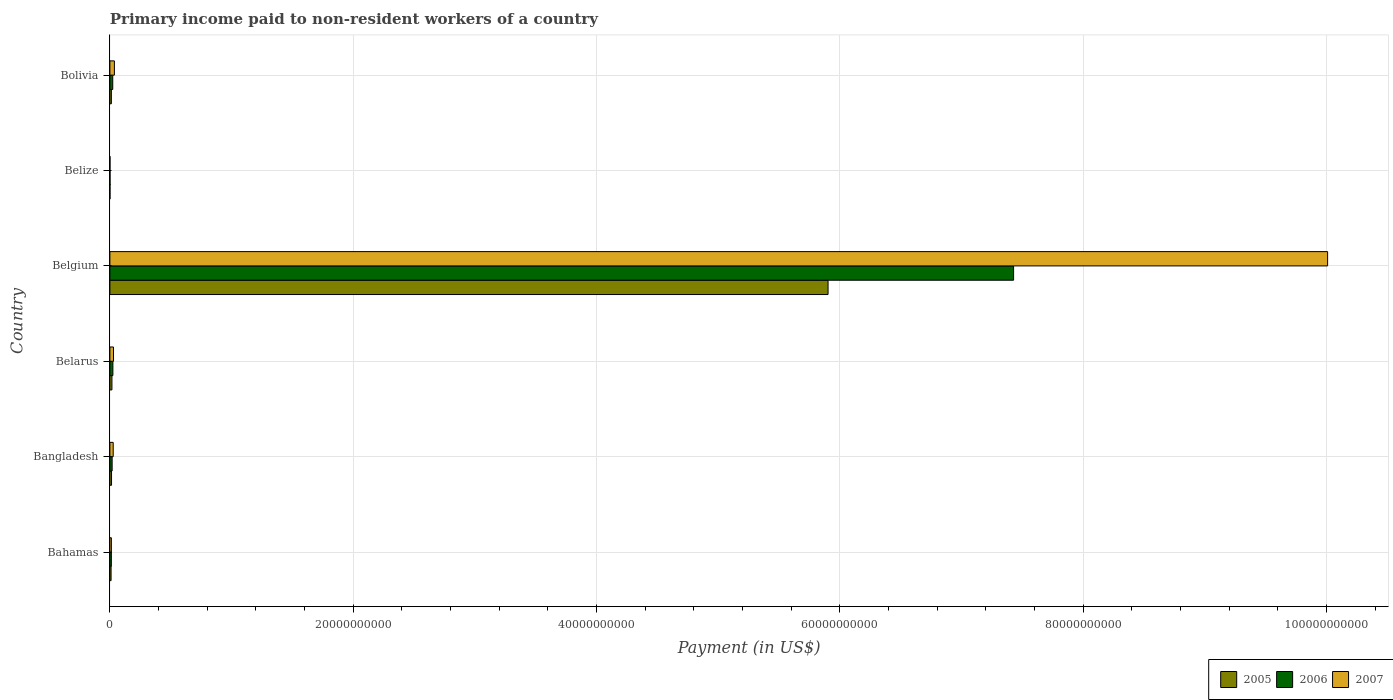How many different coloured bars are there?
Your response must be concise. 3. How many groups of bars are there?
Your answer should be very brief. 6. Are the number of bars per tick equal to the number of legend labels?
Make the answer very short. Yes. Are the number of bars on each tick of the Y-axis equal?
Make the answer very short. Yes. How many bars are there on the 6th tick from the top?
Give a very brief answer. 3. What is the amount paid to workers in 2006 in Belize?
Make the answer very short. 1.01e+07. Across all countries, what is the maximum amount paid to workers in 2005?
Keep it short and to the point. 5.90e+1. Across all countries, what is the minimum amount paid to workers in 2007?
Keep it short and to the point. 6.97e+06. In which country was the amount paid to workers in 2006 maximum?
Your response must be concise. Belgium. In which country was the amount paid to workers in 2006 minimum?
Give a very brief answer. Belize. What is the total amount paid to workers in 2005 in the graph?
Keep it short and to the point. 5.96e+1. What is the difference between the amount paid to workers in 2007 in Bangladesh and that in Belgium?
Your answer should be very brief. -9.98e+1. What is the difference between the amount paid to workers in 2007 in Bahamas and the amount paid to workers in 2005 in Belarus?
Keep it short and to the point. -4.71e+07. What is the average amount paid to workers in 2007 per country?
Your answer should be very brief. 1.69e+1. What is the difference between the amount paid to workers in 2007 and amount paid to workers in 2005 in Belgium?
Your response must be concise. 4.11e+1. In how many countries, is the amount paid to workers in 2007 greater than 12000000000 US$?
Ensure brevity in your answer.  1. What is the ratio of the amount paid to workers in 2005 in Belarus to that in Bolivia?
Offer a very short reply. 1.39. Is the difference between the amount paid to workers in 2007 in Belgium and Bolivia greater than the difference between the amount paid to workers in 2005 in Belgium and Bolivia?
Offer a terse response. Yes. What is the difference between the highest and the second highest amount paid to workers in 2007?
Offer a terse response. 9.97e+1. What is the difference between the highest and the lowest amount paid to workers in 2006?
Offer a very short reply. 7.43e+1. Is the sum of the amount paid to workers in 2007 in Bahamas and Belarus greater than the maximum amount paid to workers in 2005 across all countries?
Ensure brevity in your answer.  No. What does the 1st bar from the top in Bahamas represents?
Your response must be concise. 2007. What does the 2nd bar from the bottom in Bahamas represents?
Keep it short and to the point. 2006. Is it the case that in every country, the sum of the amount paid to workers in 2007 and amount paid to workers in 2005 is greater than the amount paid to workers in 2006?
Ensure brevity in your answer.  Yes. How many bars are there?
Your response must be concise. 18. Are all the bars in the graph horizontal?
Offer a terse response. Yes. How many countries are there in the graph?
Offer a very short reply. 6. What is the difference between two consecutive major ticks on the X-axis?
Offer a terse response. 2.00e+1. How many legend labels are there?
Your response must be concise. 3. What is the title of the graph?
Keep it short and to the point. Primary income paid to non-resident workers of a country. Does "1985" appear as one of the legend labels in the graph?
Provide a succinct answer. No. What is the label or title of the X-axis?
Give a very brief answer. Payment (in US$). What is the label or title of the Y-axis?
Offer a terse response. Country. What is the Payment (in US$) in 2005 in Bahamas?
Offer a terse response. 9.70e+07. What is the Payment (in US$) of 2006 in Bahamas?
Offer a very short reply. 1.19e+08. What is the Payment (in US$) in 2007 in Bahamas?
Provide a short and direct response. 1.21e+08. What is the Payment (in US$) of 2005 in Bangladesh?
Keep it short and to the point. 1.35e+08. What is the Payment (in US$) of 2006 in Bangladesh?
Keep it short and to the point. 1.84e+08. What is the Payment (in US$) of 2007 in Bangladesh?
Provide a succinct answer. 2.72e+08. What is the Payment (in US$) in 2005 in Belarus?
Keep it short and to the point. 1.68e+08. What is the Payment (in US$) in 2006 in Belarus?
Your answer should be compact. 2.47e+08. What is the Payment (in US$) in 2007 in Belarus?
Keep it short and to the point. 2.97e+08. What is the Payment (in US$) of 2005 in Belgium?
Your answer should be very brief. 5.90e+1. What is the Payment (in US$) of 2006 in Belgium?
Provide a short and direct response. 7.43e+1. What is the Payment (in US$) of 2007 in Belgium?
Provide a succinct answer. 1.00e+11. What is the Payment (in US$) of 2005 in Belize?
Provide a short and direct response. 6.78e+06. What is the Payment (in US$) in 2006 in Belize?
Keep it short and to the point. 1.01e+07. What is the Payment (in US$) in 2007 in Belize?
Provide a short and direct response. 6.97e+06. What is the Payment (in US$) in 2005 in Bolivia?
Offer a very short reply. 1.21e+08. What is the Payment (in US$) of 2006 in Bolivia?
Make the answer very short. 2.35e+08. What is the Payment (in US$) in 2007 in Bolivia?
Give a very brief answer. 3.70e+08. Across all countries, what is the maximum Payment (in US$) in 2005?
Your answer should be very brief. 5.90e+1. Across all countries, what is the maximum Payment (in US$) in 2006?
Your answer should be very brief. 7.43e+1. Across all countries, what is the maximum Payment (in US$) in 2007?
Offer a very short reply. 1.00e+11. Across all countries, what is the minimum Payment (in US$) of 2005?
Offer a very short reply. 6.78e+06. Across all countries, what is the minimum Payment (in US$) in 2006?
Your response must be concise. 1.01e+07. Across all countries, what is the minimum Payment (in US$) of 2007?
Give a very brief answer. 6.97e+06. What is the total Payment (in US$) in 2005 in the graph?
Keep it short and to the point. 5.96e+1. What is the total Payment (in US$) in 2006 in the graph?
Your answer should be very brief. 7.51e+1. What is the total Payment (in US$) of 2007 in the graph?
Offer a very short reply. 1.01e+11. What is the difference between the Payment (in US$) in 2005 in Bahamas and that in Bangladesh?
Offer a very short reply. -3.82e+07. What is the difference between the Payment (in US$) in 2006 in Bahamas and that in Bangladesh?
Make the answer very short. -6.50e+07. What is the difference between the Payment (in US$) of 2007 in Bahamas and that in Bangladesh?
Offer a very short reply. -1.50e+08. What is the difference between the Payment (in US$) of 2005 in Bahamas and that in Belarus?
Offer a very short reply. -7.14e+07. What is the difference between the Payment (in US$) in 2006 in Bahamas and that in Belarus?
Your answer should be compact. -1.27e+08. What is the difference between the Payment (in US$) in 2007 in Bahamas and that in Belarus?
Make the answer very short. -1.76e+08. What is the difference between the Payment (in US$) of 2005 in Bahamas and that in Belgium?
Provide a succinct answer. -5.89e+1. What is the difference between the Payment (in US$) of 2006 in Bahamas and that in Belgium?
Make the answer very short. -7.42e+1. What is the difference between the Payment (in US$) in 2007 in Bahamas and that in Belgium?
Ensure brevity in your answer.  -1.00e+11. What is the difference between the Payment (in US$) of 2005 in Bahamas and that in Belize?
Keep it short and to the point. 9.02e+07. What is the difference between the Payment (in US$) in 2006 in Bahamas and that in Belize?
Give a very brief answer. 1.09e+08. What is the difference between the Payment (in US$) in 2007 in Bahamas and that in Belize?
Provide a short and direct response. 1.14e+08. What is the difference between the Payment (in US$) of 2005 in Bahamas and that in Bolivia?
Offer a very short reply. -2.42e+07. What is the difference between the Payment (in US$) in 2006 in Bahamas and that in Bolivia?
Your answer should be very brief. -1.16e+08. What is the difference between the Payment (in US$) of 2007 in Bahamas and that in Bolivia?
Make the answer very short. -2.49e+08. What is the difference between the Payment (in US$) of 2005 in Bangladesh and that in Belarus?
Give a very brief answer. -3.32e+07. What is the difference between the Payment (in US$) in 2006 in Bangladesh and that in Belarus?
Keep it short and to the point. -6.22e+07. What is the difference between the Payment (in US$) in 2007 in Bangladesh and that in Belarus?
Keep it short and to the point. -2.54e+07. What is the difference between the Payment (in US$) in 2005 in Bangladesh and that in Belgium?
Your response must be concise. -5.89e+1. What is the difference between the Payment (in US$) in 2006 in Bangladesh and that in Belgium?
Provide a short and direct response. -7.41e+1. What is the difference between the Payment (in US$) in 2007 in Bangladesh and that in Belgium?
Keep it short and to the point. -9.98e+1. What is the difference between the Payment (in US$) of 2005 in Bangladesh and that in Belize?
Keep it short and to the point. 1.28e+08. What is the difference between the Payment (in US$) in 2006 in Bangladesh and that in Belize?
Offer a very short reply. 1.74e+08. What is the difference between the Payment (in US$) in 2007 in Bangladesh and that in Belize?
Offer a terse response. 2.65e+08. What is the difference between the Payment (in US$) of 2005 in Bangladesh and that in Bolivia?
Offer a terse response. 1.39e+07. What is the difference between the Payment (in US$) in 2006 in Bangladesh and that in Bolivia?
Give a very brief answer. -5.10e+07. What is the difference between the Payment (in US$) of 2007 in Bangladesh and that in Bolivia?
Offer a terse response. -9.81e+07. What is the difference between the Payment (in US$) of 2005 in Belarus and that in Belgium?
Make the answer very short. -5.89e+1. What is the difference between the Payment (in US$) of 2006 in Belarus and that in Belgium?
Make the answer very short. -7.40e+1. What is the difference between the Payment (in US$) in 2007 in Belarus and that in Belgium?
Keep it short and to the point. -9.98e+1. What is the difference between the Payment (in US$) in 2005 in Belarus and that in Belize?
Make the answer very short. 1.62e+08. What is the difference between the Payment (in US$) in 2006 in Belarus and that in Belize?
Keep it short and to the point. 2.36e+08. What is the difference between the Payment (in US$) of 2007 in Belarus and that in Belize?
Offer a terse response. 2.90e+08. What is the difference between the Payment (in US$) of 2005 in Belarus and that in Bolivia?
Your response must be concise. 4.72e+07. What is the difference between the Payment (in US$) of 2006 in Belarus and that in Bolivia?
Keep it short and to the point. 1.12e+07. What is the difference between the Payment (in US$) of 2007 in Belarus and that in Bolivia?
Provide a succinct answer. -7.27e+07. What is the difference between the Payment (in US$) of 2005 in Belgium and that in Belize?
Give a very brief answer. 5.90e+1. What is the difference between the Payment (in US$) in 2006 in Belgium and that in Belize?
Make the answer very short. 7.43e+1. What is the difference between the Payment (in US$) in 2007 in Belgium and that in Belize?
Your answer should be very brief. 1.00e+11. What is the difference between the Payment (in US$) of 2005 in Belgium and that in Bolivia?
Provide a succinct answer. 5.89e+1. What is the difference between the Payment (in US$) of 2006 in Belgium and that in Bolivia?
Offer a very short reply. 7.40e+1. What is the difference between the Payment (in US$) in 2007 in Belgium and that in Bolivia?
Make the answer very short. 9.97e+1. What is the difference between the Payment (in US$) in 2005 in Belize and that in Bolivia?
Give a very brief answer. -1.14e+08. What is the difference between the Payment (in US$) in 2006 in Belize and that in Bolivia?
Your answer should be compact. -2.25e+08. What is the difference between the Payment (in US$) in 2007 in Belize and that in Bolivia?
Offer a terse response. -3.63e+08. What is the difference between the Payment (in US$) in 2005 in Bahamas and the Payment (in US$) in 2006 in Bangladesh?
Provide a succinct answer. -8.74e+07. What is the difference between the Payment (in US$) of 2005 in Bahamas and the Payment (in US$) of 2007 in Bangladesh?
Your response must be concise. -1.75e+08. What is the difference between the Payment (in US$) in 2006 in Bahamas and the Payment (in US$) in 2007 in Bangladesh?
Ensure brevity in your answer.  -1.52e+08. What is the difference between the Payment (in US$) of 2005 in Bahamas and the Payment (in US$) of 2006 in Belarus?
Offer a very short reply. -1.50e+08. What is the difference between the Payment (in US$) in 2005 in Bahamas and the Payment (in US$) in 2007 in Belarus?
Make the answer very short. -2.00e+08. What is the difference between the Payment (in US$) of 2006 in Bahamas and the Payment (in US$) of 2007 in Belarus?
Provide a succinct answer. -1.78e+08. What is the difference between the Payment (in US$) of 2005 in Bahamas and the Payment (in US$) of 2006 in Belgium?
Your answer should be compact. -7.42e+1. What is the difference between the Payment (in US$) in 2005 in Bahamas and the Payment (in US$) in 2007 in Belgium?
Keep it short and to the point. -1.00e+11. What is the difference between the Payment (in US$) of 2006 in Bahamas and the Payment (in US$) of 2007 in Belgium?
Offer a very short reply. -1.00e+11. What is the difference between the Payment (in US$) of 2005 in Bahamas and the Payment (in US$) of 2006 in Belize?
Offer a terse response. 8.69e+07. What is the difference between the Payment (in US$) in 2005 in Bahamas and the Payment (in US$) in 2007 in Belize?
Your answer should be very brief. 9.00e+07. What is the difference between the Payment (in US$) of 2006 in Bahamas and the Payment (in US$) of 2007 in Belize?
Your answer should be compact. 1.12e+08. What is the difference between the Payment (in US$) of 2005 in Bahamas and the Payment (in US$) of 2006 in Bolivia?
Your answer should be compact. -1.38e+08. What is the difference between the Payment (in US$) in 2005 in Bahamas and the Payment (in US$) in 2007 in Bolivia?
Make the answer very short. -2.73e+08. What is the difference between the Payment (in US$) in 2006 in Bahamas and the Payment (in US$) in 2007 in Bolivia?
Your answer should be compact. -2.50e+08. What is the difference between the Payment (in US$) of 2005 in Bangladesh and the Payment (in US$) of 2006 in Belarus?
Offer a terse response. -1.11e+08. What is the difference between the Payment (in US$) of 2005 in Bangladesh and the Payment (in US$) of 2007 in Belarus?
Provide a short and direct response. -1.62e+08. What is the difference between the Payment (in US$) of 2006 in Bangladesh and the Payment (in US$) of 2007 in Belarus?
Offer a terse response. -1.13e+08. What is the difference between the Payment (in US$) in 2005 in Bangladesh and the Payment (in US$) in 2006 in Belgium?
Give a very brief answer. -7.41e+1. What is the difference between the Payment (in US$) of 2005 in Bangladesh and the Payment (in US$) of 2007 in Belgium?
Provide a succinct answer. -1.00e+11. What is the difference between the Payment (in US$) in 2006 in Bangladesh and the Payment (in US$) in 2007 in Belgium?
Offer a terse response. -9.99e+1. What is the difference between the Payment (in US$) in 2005 in Bangladesh and the Payment (in US$) in 2006 in Belize?
Ensure brevity in your answer.  1.25e+08. What is the difference between the Payment (in US$) of 2005 in Bangladesh and the Payment (in US$) of 2007 in Belize?
Offer a very short reply. 1.28e+08. What is the difference between the Payment (in US$) in 2006 in Bangladesh and the Payment (in US$) in 2007 in Belize?
Offer a terse response. 1.77e+08. What is the difference between the Payment (in US$) in 2005 in Bangladesh and the Payment (in US$) in 2006 in Bolivia?
Make the answer very short. -1.00e+08. What is the difference between the Payment (in US$) in 2005 in Bangladesh and the Payment (in US$) in 2007 in Bolivia?
Provide a short and direct response. -2.35e+08. What is the difference between the Payment (in US$) of 2006 in Bangladesh and the Payment (in US$) of 2007 in Bolivia?
Give a very brief answer. -1.85e+08. What is the difference between the Payment (in US$) of 2005 in Belarus and the Payment (in US$) of 2006 in Belgium?
Your answer should be very brief. -7.41e+1. What is the difference between the Payment (in US$) in 2005 in Belarus and the Payment (in US$) in 2007 in Belgium?
Provide a short and direct response. -9.99e+1. What is the difference between the Payment (in US$) of 2006 in Belarus and the Payment (in US$) of 2007 in Belgium?
Provide a short and direct response. -9.98e+1. What is the difference between the Payment (in US$) in 2005 in Belarus and the Payment (in US$) in 2006 in Belize?
Keep it short and to the point. 1.58e+08. What is the difference between the Payment (in US$) in 2005 in Belarus and the Payment (in US$) in 2007 in Belize?
Keep it short and to the point. 1.61e+08. What is the difference between the Payment (in US$) of 2006 in Belarus and the Payment (in US$) of 2007 in Belize?
Give a very brief answer. 2.40e+08. What is the difference between the Payment (in US$) in 2005 in Belarus and the Payment (in US$) in 2006 in Bolivia?
Your response must be concise. -6.70e+07. What is the difference between the Payment (in US$) of 2005 in Belarus and the Payment (in US$) of 2007 in Bolivia?
Provide a short and direct response. -2.01e+08. What is the difference between the Payment (in US$) in 2006 in Belarus and the Payment (in US$) in 2007 in Bolivia?
Your answer should be very brief. -1.23e+08. What is the difference between the Payment (in US$) of 2005 in Belgium and the Payment (in US$) of 2006 in Belize?
Your answer should be very brief. 5.90e+1. What is the difference between the Payment (in US$) of 2005 in Belgium and the Payment (in US$) of 2007 in Belize?
Keep it short and to the point. 5.90e+1. What is the difference between the Payment (in US$) in 2006 in Belgium and the Payment (in US$) in 2007 in Belize?
Ensure brevity in your answer.  7.43e+1. What is the difference between the Payment (in US$) of 2005 in Belgium and the Payment (in US$) of 2006 in Bolivia?
Your answer should be compact. 5.88e+1. What is the difference between the Payment (in US$) of 2005 in Belgium and the Payment (in US$) of 2007 in Bolivia?
Make the answer very short. 5.87e+1. What is the difference between the Payment (in US$) of 2006 in Belgium and the Payment (in US$) of 2007 in Bolivia?
Offer a terse response. 7.39e+1. What is the difference between the Payment (in US$) of 2005 in Belize and the Payment (in US$) of 2006 in Bolivia?
Your response must be concise. -2.29e+08. What is the difference between the Payment (in US$) in 2005 in Belize and the Payment (in US$) in 2007 in Bolivia?
Ensure brevity in your answer.  -3.63e+08. What is the difference between the Payment (in US$) of 2006 in Belize and the Payment (in US$) of 2007 in Bolivia?
Your answer should be compact. -3.60e+08. What is the average Payment (in US$) of 2005 per country?
Offer a terse response. 9.93e+09. What is the average Payment (in US$) in 2006 per country?
Keep it short and to the point. 1.25e+1. What is the average Payment (in US$) of 2007 per country?
Offer a terse response. 1.69e+1. What is the difference between the Payment (in US$) of 2005 and Payment (in US$) of 2006 in Bahamas?
Provide a succinct answer. -2.24e+07. What is the difference between the Payment (in US$) of 2005 and Payment (in US$) of 2007 in Bahamas?
Your answer should be very brief. -2.43e+07. What is the difference between the Payment (in US$) in 2006 and Payment (in US$) in 2007 in Bahamas?
Your response must be concise. -1.88e+06. What is the difference between the Payment (in US$) in 2005 and Payment (in US$) in 2006 in Bangladesh?
Your answer should be compact. -4.93e+07. What is the difference between the Payment (in US$) in 2005 and Payment (in US$) in 2007 in Bangladesh?
Your answer should be very brief. -1.37e+08. What is the difference between the Payment (in US$) of 2006 and Payment (in US$) of 2007 in Bangladesh?
Offer a terse response. -8.73e+07. What is the difference between the Payment (in US$) of 2005 and Payment (in US$) of 2006 in Belarus?
Your answer should be very brief. -7.82e+07. What is the difference between the Payment (in US$) of 2005 and Payment (in US$) of 2007 in Belarus?
Provide a short and direct response. -1.29e+08. What is the difference between the Payment (in US$) in 2006 and Payment (in US$) in 2007 in Belarus?
Your response must be concise. -5.05e+07. What is the difference between the Payment (in US$) in 2005 and Payment (in US$) in 2006 in Belgium?
Give a very brief answer. -1.52e+1. What is the difference between the Payment (in US$) of 2005 and Payment (in US$) of 2007 in Belgium?
Provide a succinct answer. -4.11e+1. What is the difference between the Payment (in US$) in 2006 and Payment (in US$) in 2007 in Belgium?
Keep it short and to the point. -2.58e+1. What is the difference between the Payment (in US$) in 2005 and Payment (in US$) in 2006 in Belize?
Provide a succinct answer. -3.32e+06. What is the difference between the Payment (in US$) in 2005 and Payment (in US$) in 2007 in Belize?
Your answer should be very brief. -1.86e+05. What is the difference between the Payment (in US$) in 2006 and Payment (in US$) in 2007 in Belize?
Provide a short and direct response. 3.13e+06. What is the difference between the Payment (in US$) in 2005 and Payment (in US$) in 2006 in Bolivia?
Offer a very short reply. -1.14e+08. What is the difference between the Payment (in US$) in 2005 and Payment (in US$) in 2007 in Bolivia?
Provide a short and direct response. -2.49e+08. What is the difference between the Payment (in US$) of 2006 and Payment (in US$) of 2007 in Bolivia?
Make the answer very short. -1.34e+08. What is the ratio of the Payment (in US$) in 2005 in Bahamas to that in Bangladesh?
Provide a succinct answer. 0.72. What is the ratio of the Payment (in US$) in 2006 in Bahamas to that in Bangladesh?
Offer a very short reply. 0.65. What is the ratio of the Payment (in US$) of 2007 in Bahamas to that in Bangladesh?
Provide a succinct answer. 0.45. What is the ratio of the Payment (in US$) of 2005 in Bahamas to that in Belarus?
Make the answer very short. 0.58. What is the ratio of the Payment (in US$) in 2006 in Bahamas to that in Belarus?
Offer a very short reply. 0.48. What is the ratio of the Payment (in US$) of 2007 in Bahamas to that in Belarus?
Offer a terse response. 0.41. What is the ratio of the Payment (in US$) of 2005 in Bahamas to that in Belgium?
Your answer should be very brief. 0. What is the ratio of the Payment (in US$) in 2006 in Bahamas to that in Belgium?
Provide a short and direct response. 0. What is the ratio of the Payment (in US$) of 2007 in Bahamas to that in Belgium?
Offer a very short reply. 0. What is the ratio of the Payment (in US$) in 2005 in Bahamas to that in Belize?
Your response must be concise. 14.3. What is the ratio of the Payment (in US$) of 2006 in Bahamas to that in Belize?
Ensure brevity in your answer.  11.82. What is the ratio of the Payment (in US$) in 2007 in Bahamas to that in Belize?
Make the answer very short. 17.41. What is the ratio of the Payment (in US$) in 2005 in Bahamas to that in Bolivia?
Offer a terse response. 0.8. What is the ratio of the Payment (in US$) of 2006 in Bahamas to that in Bolivia?
Keep it short and to the point. 0.51. What is the ratio of the Payment (in US$) in 2007 in Bahamas to that in Bolivia?
Give a very brief answer. 0.33. What is the ratio of the Payment (in US$) in 2005 in Bangladesh to that in Belarus?
Provide a succinct answer. 0.8. What is the ratio of the Payment (in US$) in 2006 in Bangladesh to that in Belarus?
Give a very brief answer. 0.75. What is the ratio of the Payment (in US$) in 2007 in Bangladesh to that in Belarus?
Give a very brief answer. 0.91. What is the ratio of the Payment (in US$) of 2005 in Bangladesh to that in Belgium?
Make the answer very short. 0. What is the ratio of the Payment (in US$) in 2006 in Bangladesh to that in Belgium?
Provide a succinct answer. 0. What is the ratio of the Payment (in US$) of 2007 in Bangladesh to that in Belgium?
Your answer should be compact. 0. What is the ratio of the Payment (in US$) in 2005 in Bangladesh to that in Belize?
Provide a succinct answer. 19.93. What is the ratio of the Payment (in US$) in 2006 in Bangladesh to that in Belize?
Offer a very short reply. 18.26. What is the ratio of the Payment (in US$) in 2007 in Bangladesh to that in Belize?
Your response must be concise. 39. What is the ratio of the Payment (in US$) in 2005 in Bangladesh to that in Bolivia?
Your answer should be very brief. 1.11. What is the ratio of the Payment (in US$) of 2006 in Bangladesh to that in Bolivia?
Ensure brevity in your answer.  0.78. What is the ratio of the Payment (in US$) of 2007 in Bangladesh to that in Bolivia?
Your answer should be very brief. 0.73. What is the ratio of the Payment (in US$) of 2005 in Belarus to that in Belgium?
Keep it short and to the point. 0. What is the ratio of the Payment (in US$) in 2006 in Belarus to that in Belgium?
Your answer should be compact. 0. What is the ratio of the Payment (in US$) of 2007 in Belarus to that in Belgium?
Give a very brief answer. 0. What is the ratio of the Payment (in US$) in 2005 in Belarus to that in Belize?
Offer a very short reply. 24.83. What is the ratio of the Payment (in US$) in 2006 in Belarus to that in Belize?
Offer a very short reply. 24.41. What is the ratio of the Payment (in US$) of 2007 in Belarus to that in Belize?
Your answer should be very brief. 42.65. What is the ratio of the Payment (in US$) of 2005 in Belarus to that in Bolivia?
Keep it short and to the point. 1.39. What is the ratio of the Payment (in US$) in 2006 in Belarus to that in Bolivia?
Keep it short and to the point. 1.05. What is the ratio of the Payment (in US$) of 2007 in Belarus to that in Bolivia?
Ensure brevity in your answer.  0.8. What is the ratio of the Payment (in US$) in 2005 in Belgium to that in Belize?
Your answer should be compact. 8704.96. What is the ratio of the Payment (in US$) in 2006 in Belgium to that in Belize?
Provide a short and direct response. 7353.89. What is the ratio of the Payment (in US$) in 2007 in Belgium to that in Belize?
Provide a short and direct response. 1.44e+04. What is the ratio of the Payment (in US$) in 2005 in Belgium to that in Bolivia?
Keep it short and to the point. 486.92. What is the ratio of the Payment (in US$) of 2006 in Belgium to that in Bolivia?
Your response must be concise. 315.48. What is the ratio of the Payment (in US$) in 2007 in Belgium to that in Bolivia?
Your answer should be compact. 270.62. What is the ratio of the Payment (in US$) of 2005 in Belize to that in Bolivia?
Make the answer very short. 0.06. What is the ratio of the Payment (in US$) of 2006 in Belize to that in Bolivia?
Provide a succinct answer. 0.04. What is the ratio of the Payment (in US$) of 2007 in Belize to that in Bolivia?
Make the answer very short. 0.02. What is the difference between the highest and the second highest Payment (in US$) in 2005?
Your answer should be compact. 5.89e+1. What is the difference between the highest and the second highest Payment (in US$) in 2006?
Offer a terse response. 7.40e+1. What is the difference between the highest and the second highest Payment (in US$) of 2007?
Offer a very short reply. 9.97e+1. What is the difference between the highest and the lowest Payment (in US$) of 2005?
Provide a short and direct response. 5.90e+1. What is the difference between the highest and the lowest Payment (in US$) in 2006?
Give a very brief answer. 7.43e+1. What is the difference between the highest and the lowest Payment (in US$) of 2007?
Offer a very short reply. 1.00e+11. 